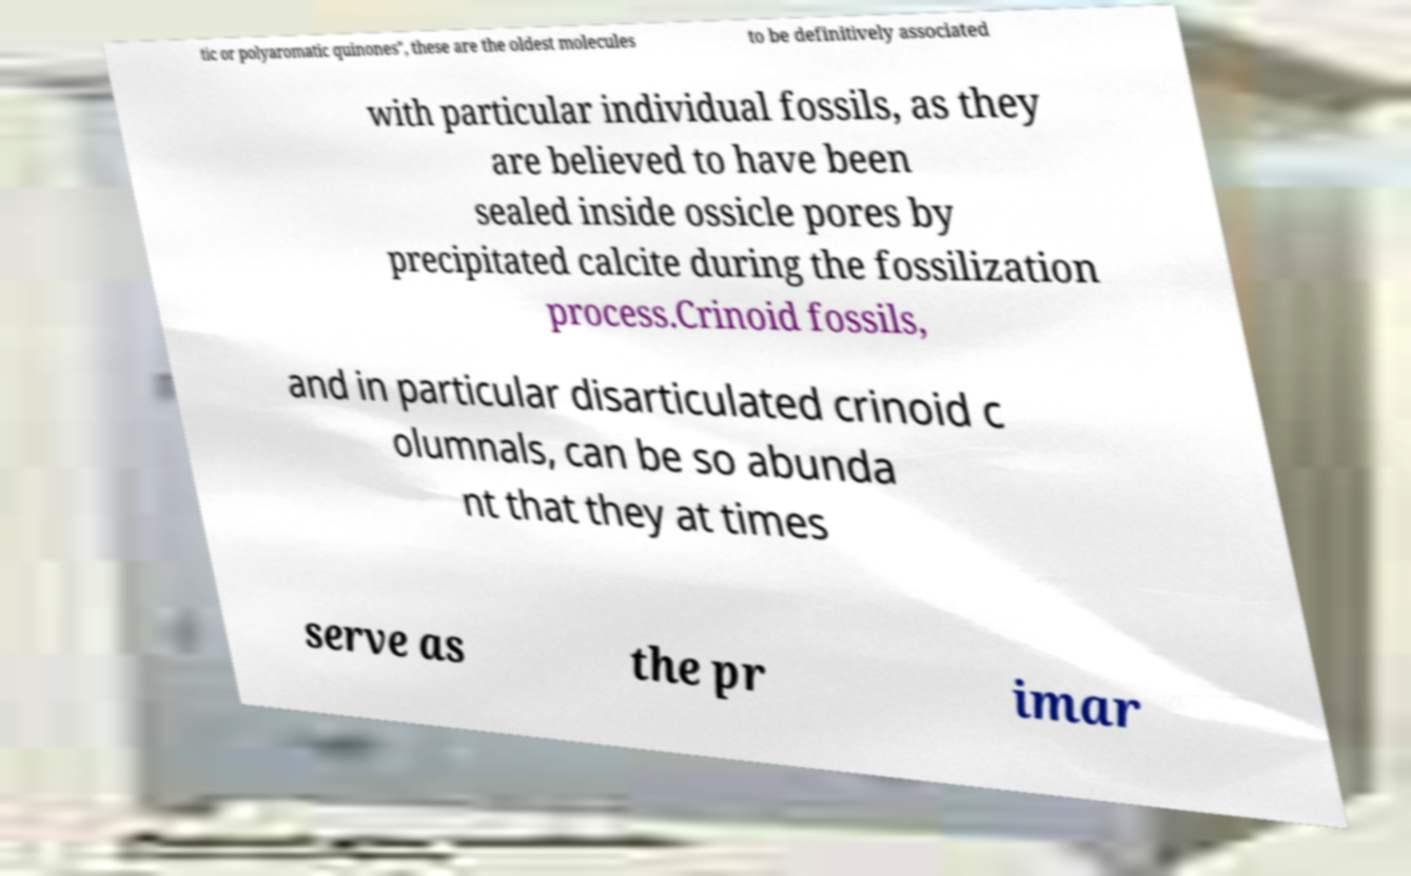Could you extract and type out the text from this image? tic or polyaromatic quinones", these are the oldest molecules to be definitively associated with particular individual fossils, as they are believed to have been sealed inside ossicle pores by precipitated calcite during the fossilization process.Crinoid fossils, and in particular disarticulated crinoid c olumnals, can be so abunda nt that they at times serve as the pr imar 